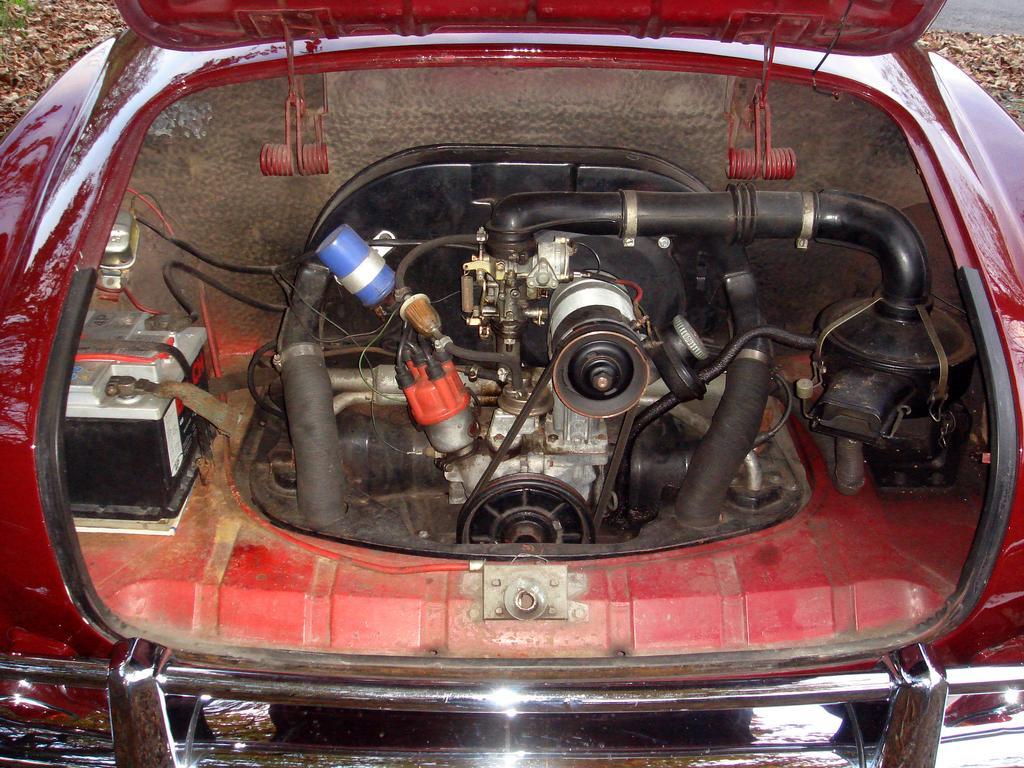How would you summarize this image in a sentence or two? In this image, we can see back view of a car with some electrical instrument. In the background, we can see a land. 